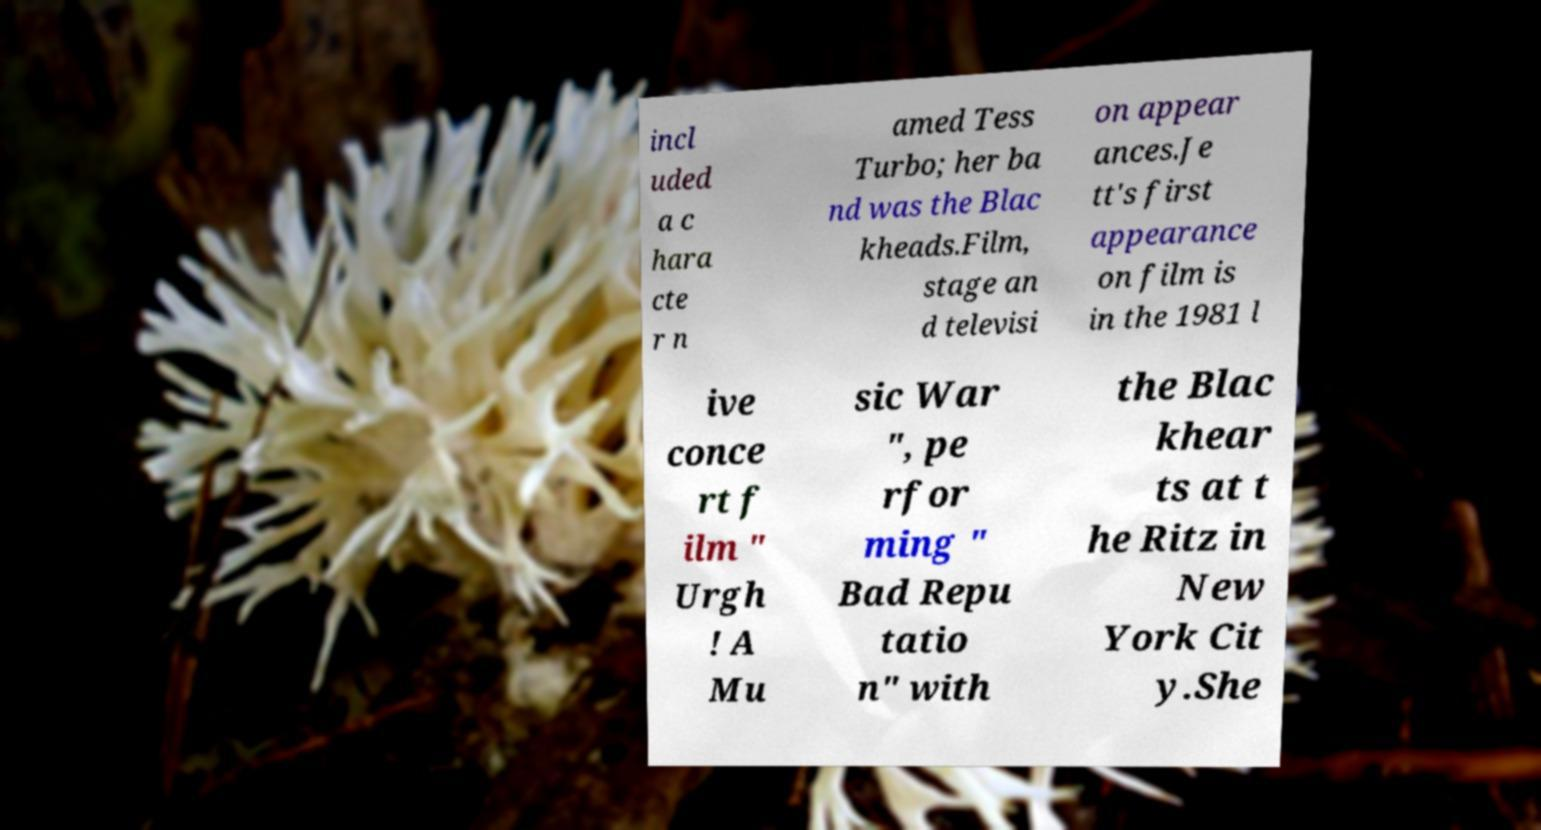There's text embedded in this image that I need extracted. Can you transcribe it verbatim? incl uded a c hara cte r n amed Tess Turbo; her ba nd was the Blac kheads.Film, stage an d televisi on appear ances.Je tt's first appearance on film is in the 1981 l ive conce rt f ilm " Urgh ! A Mu sic War ", pe rfor ming " Bad Repu tatio n" with the Blac khear ts at t he Ritz in New York Cit y.She 